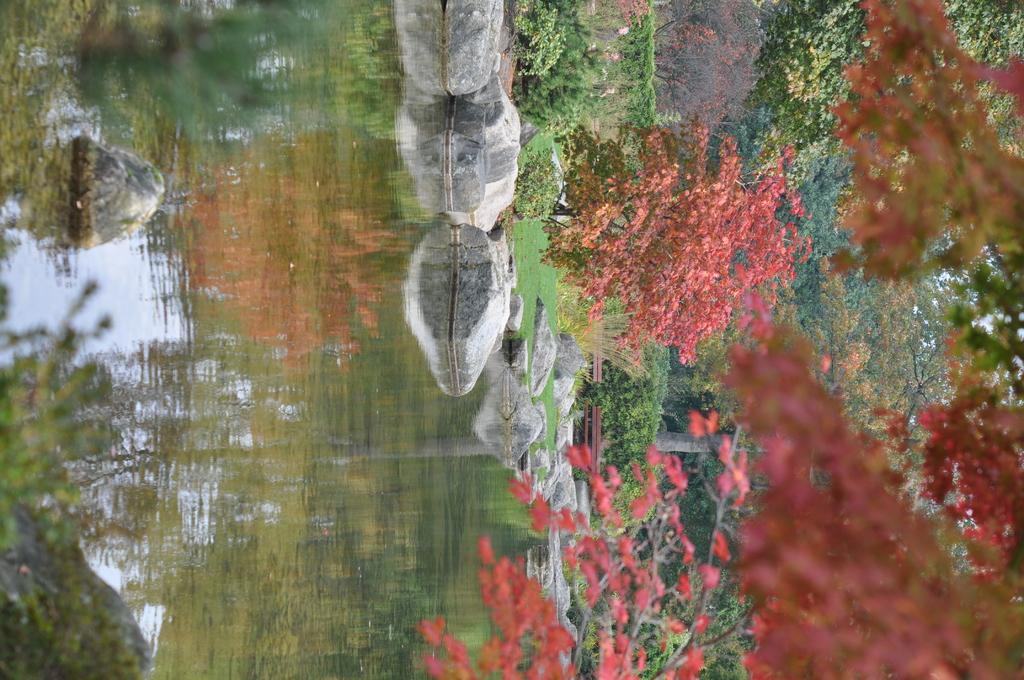What is the primary element in the image? The image consists of water. What can be seen in the middle of the image? There are rocks and plants in the middle of the image. What is unique about the plants in the image? The leaves of the plants are red in color. What can be seen in the background of the image? There are trees in the background of the image. What type of zephyr can be seen blowing through the image? There is no zephyr present in the image; it is a still image of water, rocks, and plants. Is there a hospital visible in the image? No, there is no hospital present in the image; it features water, rocks, plants, and trees. 